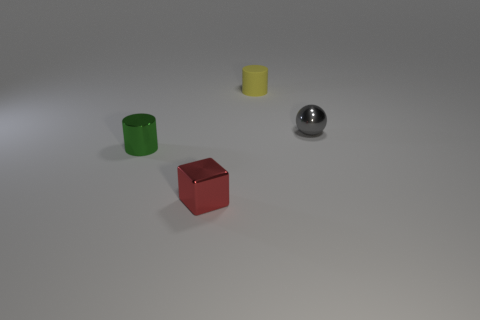Is there anything else that has the same material as the small yellow thing?
Offer a terse response. No. Are there any matte objects of the same size as the gray metallic thing?
Make the answer very short. Yes. What material is the yellow cylinder that is the same size as the sphere?
Provide a short and direct response. Rubber. There is a yellow rubber cylinder; is it the same size as the cylinder that is in front of the gray thing?
Keep it short and to the point. Yes. How many matte things are objects or tiny cylinders?
Keep it short and to the point. 1. How many green metallic things are the same shape as the tiny gray shiny object?
Your response must be concise. 0. There is a cylinder to the left of the tiny matte thing; does it have the same size as the yellow matte object that is behind the metal cube?
Keep it short and to the point. Yes. There is a small red shiny thing in front of the tiny metal sphere; what is its shape?
Your answer should be compact. Cube. What is the material of the green object that is the same shape as the small yellow rubber thing?
Your response must be concise. Metal. There is a cylinder behind the gray shiny sphere; is its size the same as the tiny metallic cylinder?
Ensure brevity in your answer.  Yes. 